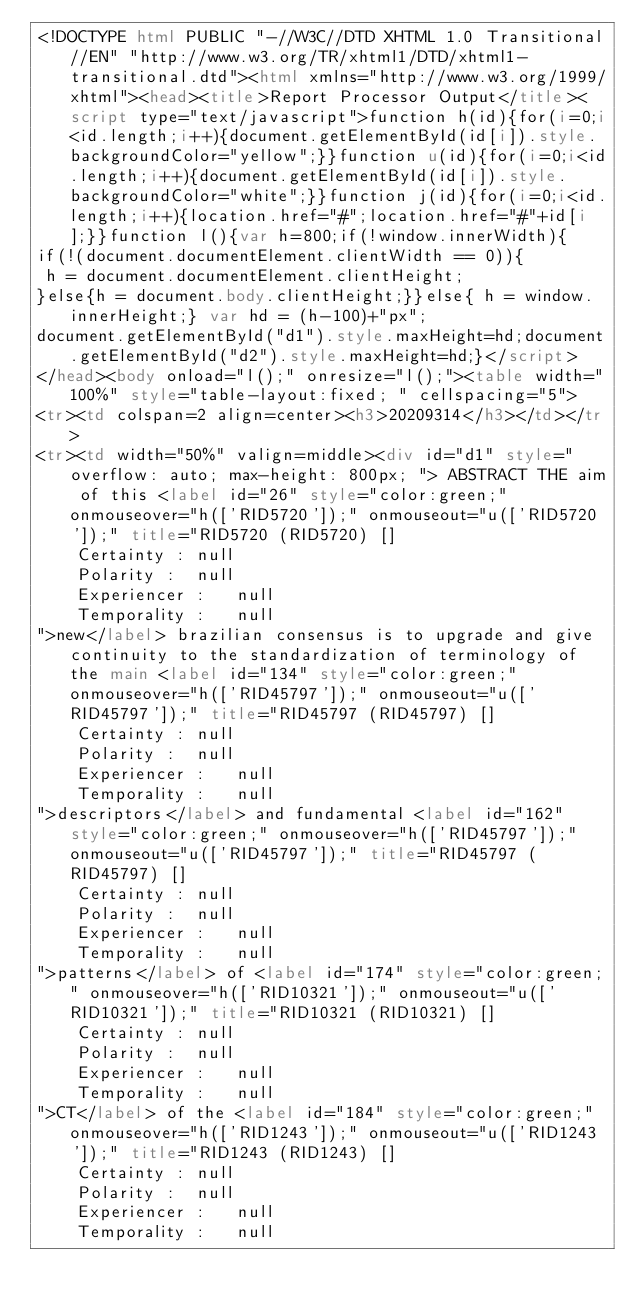<code> <loc_0><loc_0><loc_500><loc_500><_HTML_><!DOCTYPE html PUBLIC "-//W3C//DTD XHTML 1.0 Transitional//EN" "http://www.w3.org/TR/xhtml1/DTD/xhtml1-transitional.dtd"><html xmlns="http://www.w3.org/1999/xhtml"><head><title>Report Processor Output</title><script type="text/javascript">function h(id){for(i=0;i<id.length;i++){document.getElementById(id[i]).style.backgroundColor="yellow";}}function u(id){for(i=0;i<id.length;i++){document.getElementById(id[i]).style.backgroundColor="white";}}function j(id){for(i=0;i<id.length;i++){location.href="#";location.href="#"+id[i];}}function l(){var h=800;if(!window.innerWidth){
if(!(document.documentElement.clientWidth == 0)){
 h = document.documentElement.clientHeight;
}else{h = document.body.clientHeight;}}else{ h = window.innerHeight;} var hd = (h-100)+"px";
document.getElementById("d1").style.maxHeight=hd;document.getElementById("d2").style.maxHeight=hd;}</script>
</head><body onload="l();" onresize="l();"><table width="100%" style="table-layout:fixed; " cellspacing="5">
<tr><td colspan=2 align=center><h3>20209314</h3></td></tr>
<tr><td width="50%" valign=middle><div id="d1" style="overflow: auto; max-height: 800px; "> ABSTRACT THE aim of this <label id="26" style="color:green;" onmouseover="h(['RID5720']);" onmouseout="u(['RID5720']);" title="RID5720 (RID5720) []
	Certainty :	null
	Polarity :	null
	Experiencer :	null
	Temporality :	null
">new</label> brazilian consensus is to upgrade and give continuity to the standardization of terminology of the main <label id="134" style="color:green;" onmouseover="h(['RID45797']);" onmouseout="u(['RID45797']);" title="RID45797 (RID45797) []
	Certainty :	null
	Polarity :	null
	Experiencer :	null
	Temporality :	null
">descriptors</label> and fundamental <label id="162" style="color:green;" onmouseover="h(['RID45797']);" onmouseout="u(['RID45797']);" title="RID45797 (RID45797) []
	Certainty :	null
	Polarity :	null
	Experiencer :	null
	Temporality :	null
">patterns</label> of <label id="174" style="color:green;" onmouseover="h(['RID10321']);" onmouseout="u(['RID10321']);" title="RID10321 (RID10321) []
	Certainty :	null
	Polarity :	null
	Experiencer :	null
	Temporality :	null
">CT</label> of the <label id="184" style="color:green;" onmouseover="h(['RID1243']);" onmouseout="u(['RID1243']);" title="RID1243 (RID1243) []
	Certainty :	null
	Polarity :	null
	Experiencer :	null
	Temporality :	null</code> 